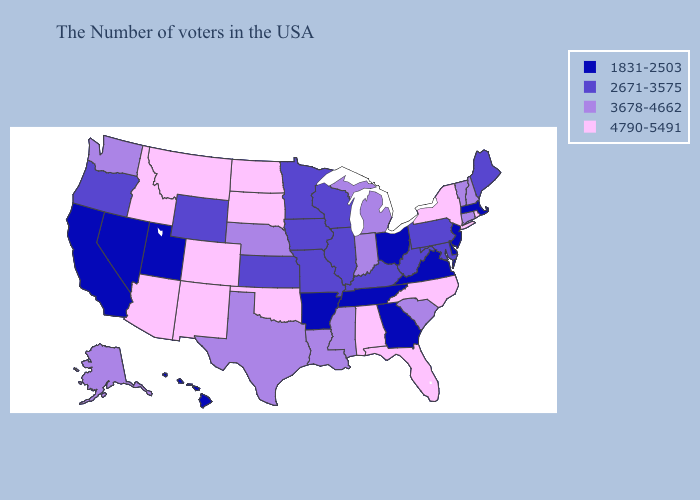What is the value of Illinois?
Keep it brief. 2671-3575. Name the states that have a value in the range 2671-3575?
Be succinct. Maine, Maryland, Pennsylvania, West Virginia, Kentucky, Wisconsin, Illinois, Missouri, Minnesota, Iowa, Kansas, Wyoming, Oregon. What is the value of Florida?
Short answer required. 4790-5491. Name the states that have a value in the range 3678-4662?
Be succinct. New Hampshire, Vermont, Connecticut, South Carolina, Michigan, Indiana, Mississippi, Louisiana, Nebraska, Texas, Washington, Alaska. Does Nevada have the highest value in the West?
Answer briefly. No. What is the value of Wyoming?
Concise answer only. 2671-3575. What is the highest value in the South ?
Concise answer only. 4790-5491. Does Tennessee have the same value as West Virginia?
Answer briefly. No. Among the states that border New Jersey , does New York have the highest value?
Keep it brief. Yes. Among the states that border Louisiana , which have the lowest value?
Concise answer only. Arkansas. Which states have the highest value in the USA?
Keep it brief. Rhode Island, New York, North Carolina, Florida, Alabama, Oklahoma, South Dakota, North Dakota, Colorado, New Mexico, Montana, Arizona, Idaho. What is the value of West Virginia?
Concise answer only. 2671-3575. Name the states that have a value in the range 1831-2503?
Give a very brief answer. Massachusetts, New Jersey, Delaware, Virginia, Ohio, Georgia, Tennessee, Arkansas, Utah, Nevada, California, Hawaii. Among the states that border Utah , does Wyoming have the highest value?
Short answer required. No. 